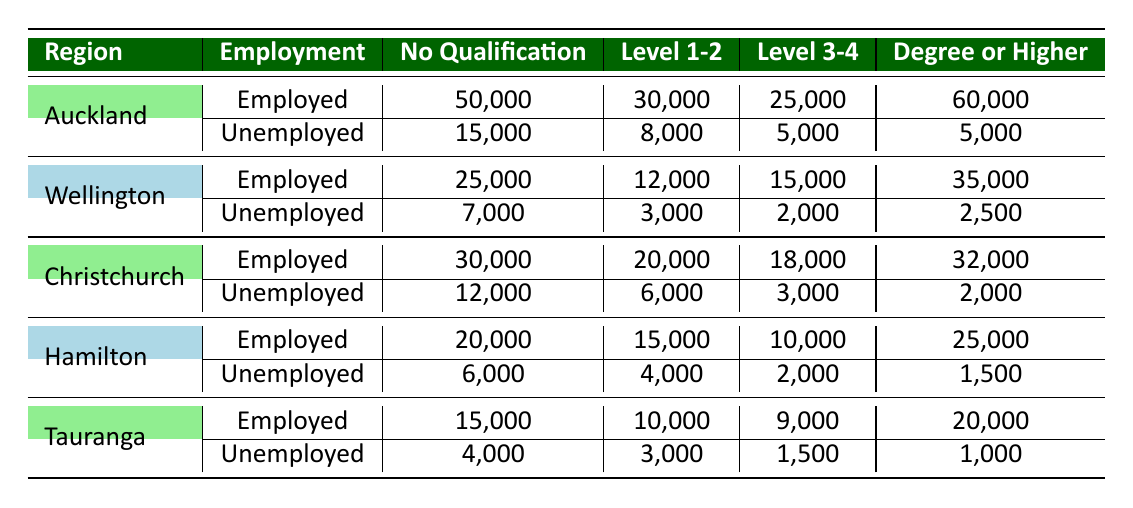What is the number of employed individuals in Auckland with a Degree or Higher? In the table, under the Auckland region, the row for Degree or Higher shows that there are 60,000 employed individuals.
Answer: 60,000 What is the total number of unemployed individuals in Wellington? In the table, under the Wellington region, we add the number of unemployed individuals for each education level: 7,000 + 3,000 + 2,000 + 2,500 = 14,500.
Answer: 14,500 Which region has the highest number of unemployed individuals without any qualification? By examining the No Qualification row for each region: Auckland has 15,000, Wellington has 7,000, Christchurch has 12,000, Hamilton has 6,000, and Tauranga has 4,000. The highest number is 15,000 in Auckland.
Answer: Auckland What is the overall employment rate in Christchurch across all education levels? First, calculate total employed in Christchurch: 30,000 + 20,000 + 18,000 + 32,000 = 100,000. Then calculate total unemployed: 12,000 + 6,000 + 3,000 + 2,000 = 23,000. The overall employment rate is 100,000 / (100,000 + 23,000) = 100,000 / 123,000 ≈ 0.813 (or 81.3%).
Answer: 81.3% Are there more employed individuals in Hamilton with a Degree or Higher than in Tauranga? In Hamilton, the number of employed individuals with a Degree or Higher is 25,000, while in Tauranga, it is 20,000. Since 25,000 is greater than 20,000, the statement is true.
Answer: Yes What is the average number of unemployed individuals across all regions for Level 3-4 education? For Level 3-4, the unemployed numbers are: Auckland 5,000, Wellington 2,000, Christchurch 3,000, Hamilton 2,000, Tauranga 1,500. The average is (5,000 + 2,000 + 3,000 + 2,000 + 1,500) / 5 = 13,500 / 5 = 2,700.
Answer: 2,700 Which education level has the lowest employment numbers in Hamilton? By checking the employment numbers for Hamilton: No Qualification 20,000, Level 1-2 15,000, Level 3-4 10,000, Degree or Higher 25,000. The lowest employment number is for Level 3-4, which is 10,000.
Answer: Level 3-4 Is it true that more individuals in Wellington with a Level 1-2 qualification are employed than unemployed? In Wellington, for Level 1-2, 12,000 are employed and 3,000 are unemployed. Since 12,000 is more than 3,000, the statement is true.
Answer: Yes What is the difference in the number of employed individuals with No Qualification between Auckland and Tauranga? From the table, Auckland has 50,000 employed without qualifications, and Tauranga has 15,000. The difference is 50,000 - 15,000 = 35,000.
Answer: 35,000 